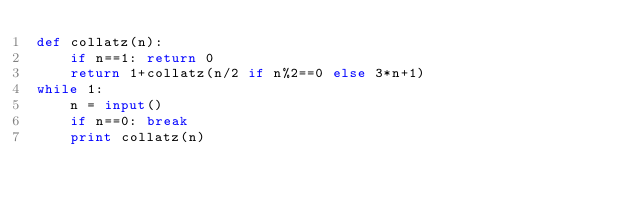Convert code to text. <code><loc_0><loc_0><loc_500><loc_500><_Python_>def collatz(n):
    if n==1: return 0
    return 1+collatz(n/2 if n%2==0 else 3*n+1)
while 1:
    n = input()
    if n==0: break
    print collatz(n)</code> 